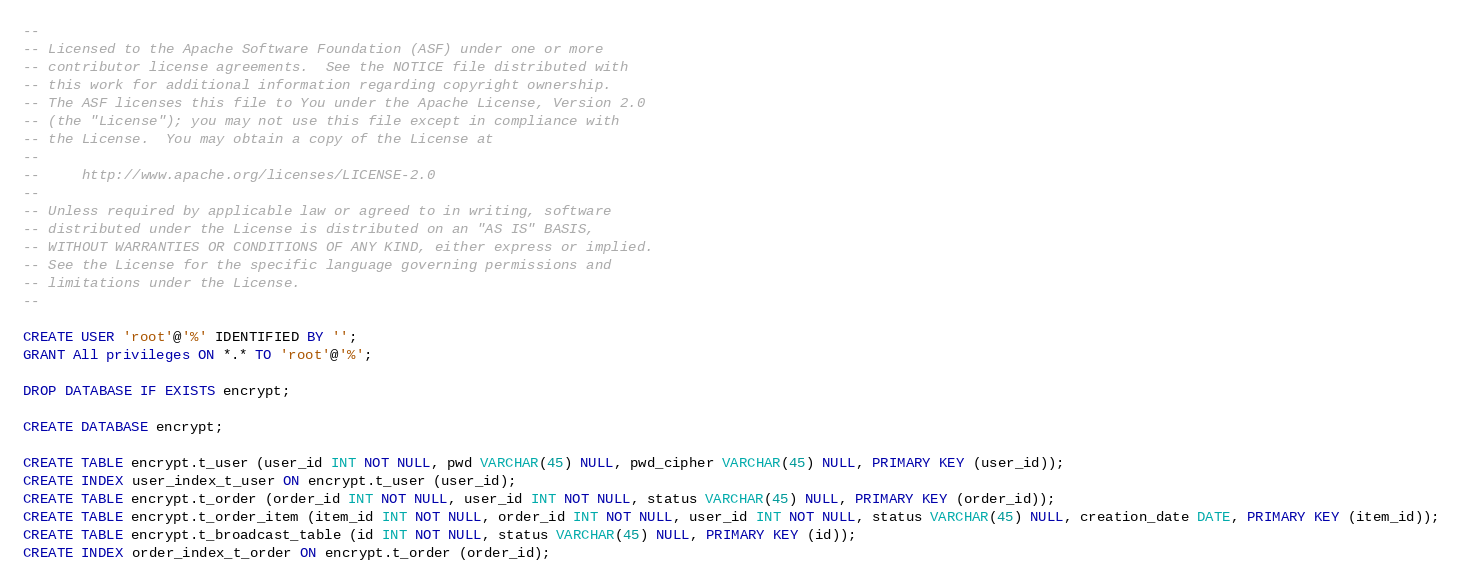<code> <loc_0><loc_0><loc_500><loc_500><_SQL_>--
-- Licensed to the Apache Software Foundation (ASF) under one or more
-- contributor license agreements.  See the NOTICE file distributed with
-- this work for additional information regarding copyright ownership.
-- The ASF licenses this file to You under the Apache License, Version 2.0
-- (the "License"); you may not use this file except in compliance with
-- the License.  You may obtain a copy of the License at
--
--     http://www.apache.org/licenses/LICENSE-2.0
--
-- Unless required by applicable law or agreed to in writing, software
-- distributed under the License is distributed on an "AS IS" BASIS,
-- WITHOUT WARRANTIES OR CONDITIONS OF ANY KIND, either express or implied.
-- See the License for the specific language governing permissions and
-- limitations under the License.
--

CREATE USER 'root'@'%' IDENTIFIED BY '';
GRANT All privileges ON *.* TO 'root'@'%';

DROP DATABASE IF EXISTS encrypt;

CREATE DATABASE encrypt;

CREATE TABLE encrypt.t_user (user_id INT NOT NULL, pwd VARCHAR(45) NULL, pwd_cipher VARCHAR(45) NULL, PRIMARY KEY (user_id));
CREATE INDEX user_index_t_user ON encrypt.t_user (user_id);
CREATE TABLE encrypt.t_order (order_id INT NOT NULL, user_id INT NOT NULL, status VARCHAR(45) NULL, PRIMARY KEY (order_id));
CREATE TABLE encrypt.t_order_item (item_id INT NOT NULL, order_id INT NOT NULL, user_id INT NOT NULL, status VARCHAR(45) NULL, creation_date DATE, PRIMARY KEY (item_id));
CREATE TABLE encrypt.t_broadcast_table (id INT NOT NULL, status VARCHAR(45) NULL, PRIMARY KEY (id));
CREATE INDEX order_index_t_order ON encrypt.t_order (order_id);
</code> 